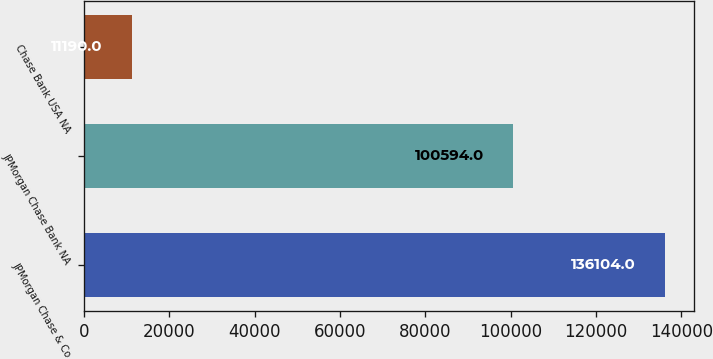Convert chart. <chart><loc_0><loc_0><loc_500><loc_500><bar_chart><fcel>JPMorgan Chase & Co<fcel>JPMorgan Chase Bank NA<fcel>Chase Bank USA NA<nl><fcel>136104<fcel>100594<fcel>11190<nl></chart> 